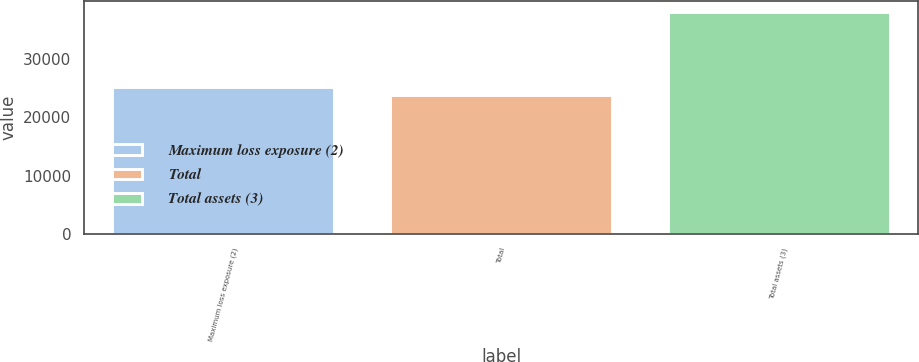<chart> <loc_0><loc_0><loc_500><loc_500><bar_chart><fcel>Maximum loss exposure (2)<fcel>Total<fcel>Total assets (3)<nl><fcel>25144.4<fcel>23720<fcel>37964<nl></chart> 